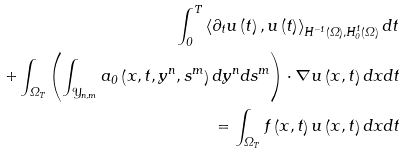<formula> <loc_0><loc_0><loc_500><loc_500>\int _ { 0 } ^ { T } \left \langle \partial _ { t } u \left ( t \right ) , u \left ( t \right ) \right \rangle _ { H ^ { - 1 } ( \Omega ) , H _ { 0 } ^ { 1 } ( \Omega ) } d t \\ + \int _ { \Omega _ { T } } \left ( \int _ { \mathcal { Y } _ { n , m } } a _ { 0 } \left ( x , t , y ^ { n } , s ^ { m } \right ) d y ^ { n } d s ^ { m } \right ) \cdot \nabla u \left ( x , t \right ) d x d t \\ = \int _ { \Omega _ { T } } f \left ( x , t \right ) u \left ( x , t \right ) d x d t</formula> 